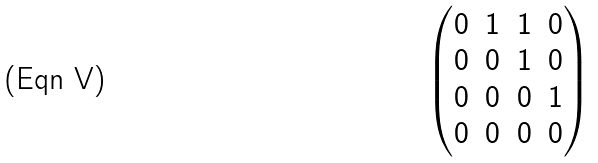Convert formula to latex. <formula><loc_0><loc_0><loc_500><loc_500>\begin{pmatrix} 0 & 1 & 1 & 0 \\ 0 & 0 & 1 & 0 \\ 0 & 0 & 0 & 1 \\ 0 & 0 & 0 & 0 \end{pmatrix}</formula> 